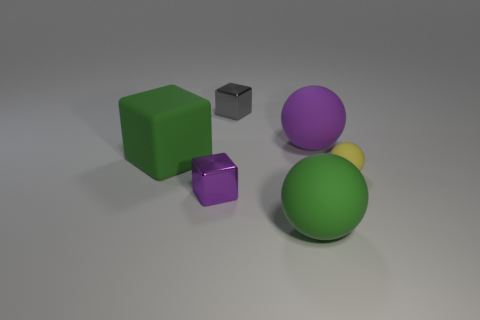Subtract all purple blocks. Subtract all yellow spheres. How many blocks are left? 2 Add 1 gray blocks. How many objects exist? 7 Add 2 tiny gray cubes. How many tiny gray cubes are left? 3 Add 3 tiny brown metal cylinders. How many tiny brown metal cylinders exist? 3 Subtract 0 blue cubes. How many objects are left? 6 Subtract all tiny gray things. Subtract all tiny yellow metal objects. How many objects are left? 5 